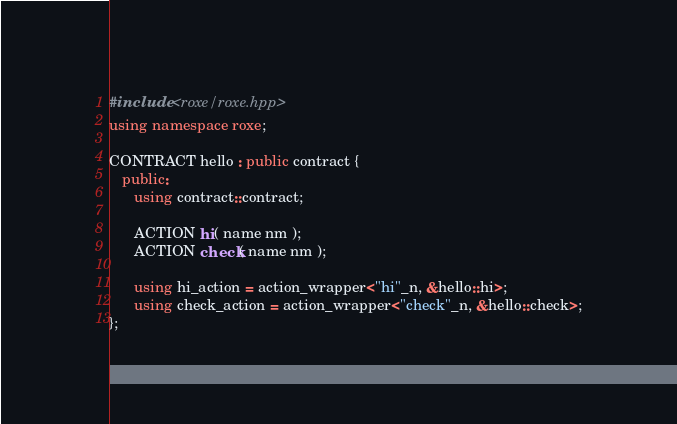Convert code to text. <code><loc_0><loc_0><loc_500><loc_500><_C++_>#include <roxe/roxe.hpp>
using namespace roxe;

CONTRACT hello : public contract {
   public:
      using contract::contract;

      ACTION hi( name nm );
      ACTION check( name nm );

      using hi_action = action_wrapper<"hi"_n, &hello::hi>;
      using check_action = action_wrapper<"check"_n, &hello::check>;
};
</code> 